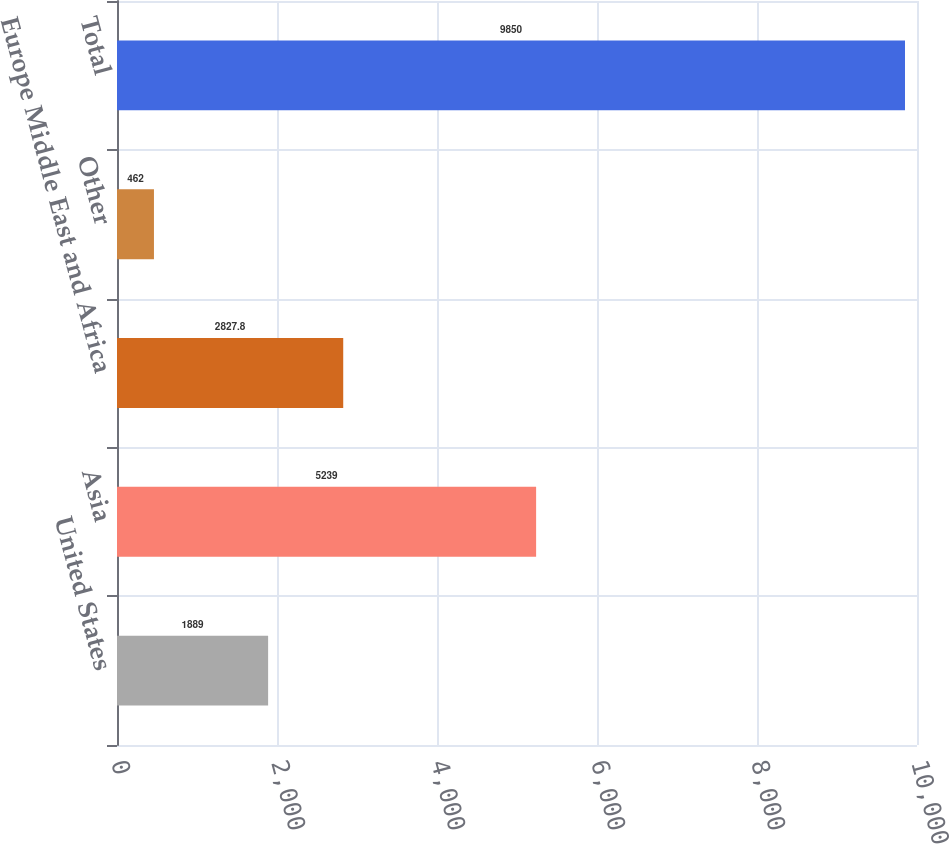<chart> <loc_0><loc_0><loc_500><loc_500><bar_chart><fcel>United States<fcel>Asia<fcel>Europe Middle East and Africa<fcel>Other<fcel>Total<nl><fcel>1889<fcel>5239<fcel>2827.8<fcel>462<fcel>9850<nl></chart> 